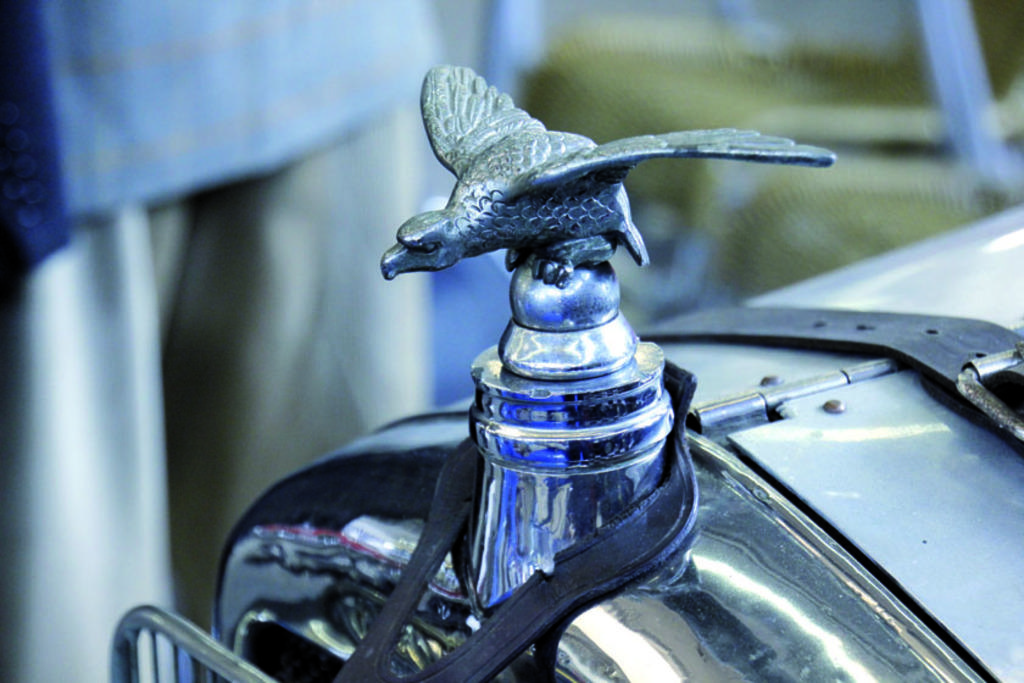What is the main subject of the image? The main subject of the image is a company logo. Where is the company logo located? The company logo is on a vehicle. Can you describe the background of the image? The background of the image is blurry. What type of stocking is the company logo wearing in the image? There is no stocking present in the image, as the subject is a company logo on a vehicle. 